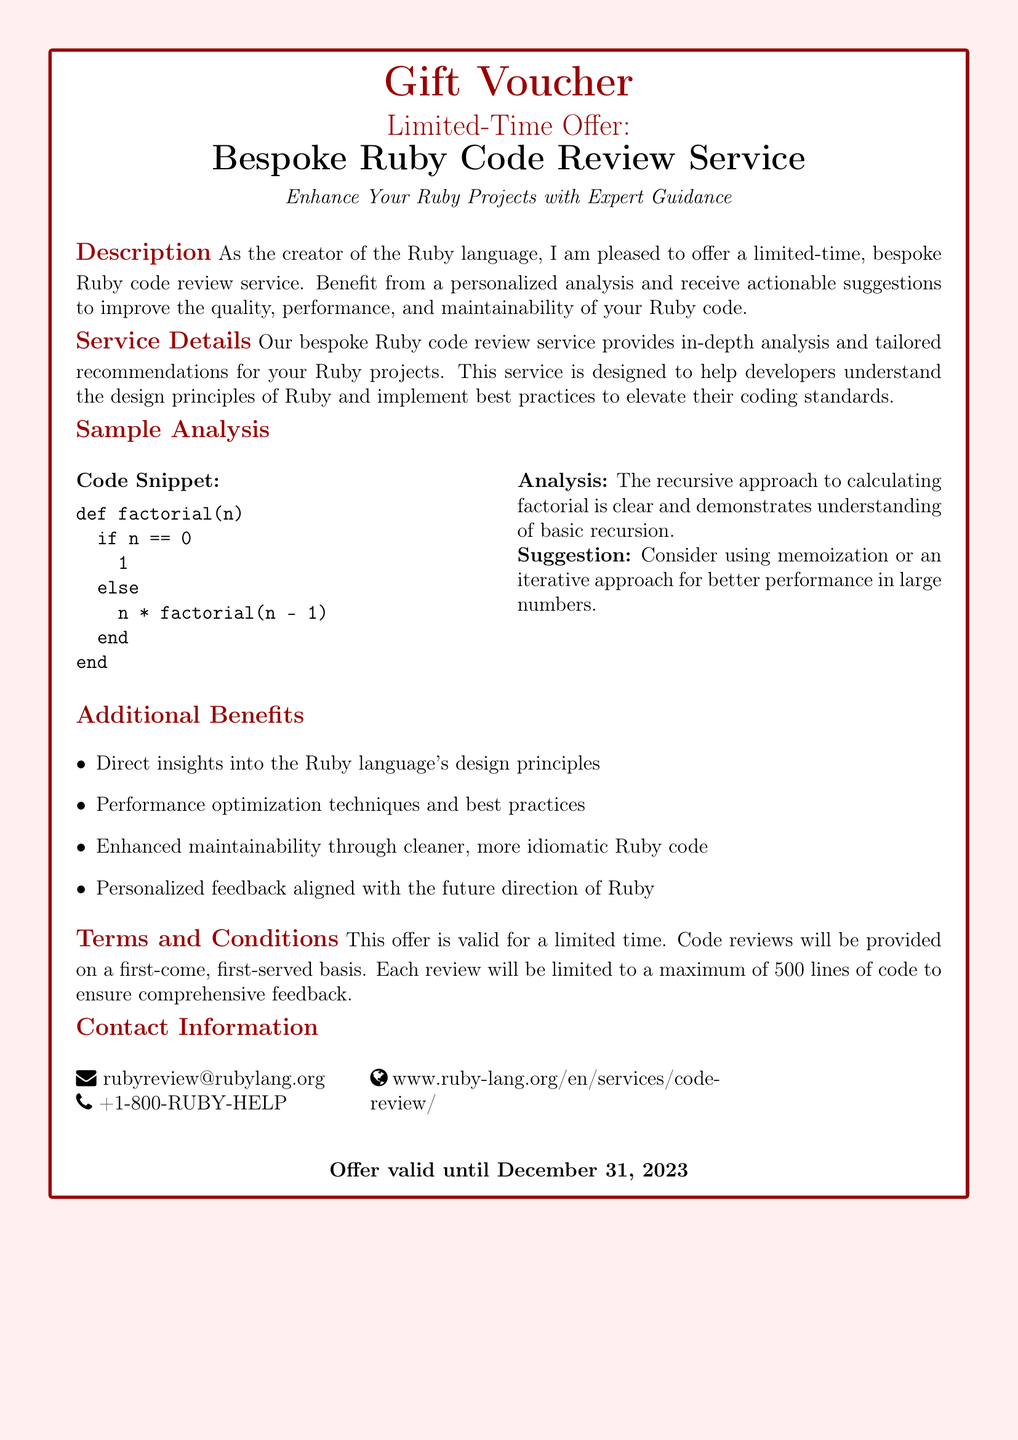What is the title of the service offered? The title of the service is prominently displayed in the document and is “Bespoke Ruby Code Review Service.”
Answer: Bespoke Ruby Code Review Service What is the maximum number of lines allowed for code reviews? The document specifies that each review will be limited to a maximum of 500 lines of code.
Answer: 500 lines When does the offer expire? The expiration date for the offer is clearly stated at the bottom of the document as December 31, 2023.
Answer: December 31, 2023 What type of analysis does the service provide? The document mentions "personalized analysis and receive actionable suggestions," indicating the approach taken in the reviews.
Answer: Personalized analysis What technique is suggested for better performance in the sample analysis? The analysis section includes a suggestion to use "memoization or an iterative approach" for improved performance.
Answer: Memoization What contact method is provided for inquiries? The document includes an email address for questions, which is "rubyreview@rubylang.org."
Answer: rubyreview@rubylang.org What specific additional benefit is mentioned in the document? The document lists multiple benefits, and one is "Direct insights into the Ruby language's design principles."
Answer: Direct insights into design principles What does the offer enhance? The document clearly states that the service aims to "Enhance Your Ruby Projects with Expert Guidance."
Answer: Enhance Your Ruby Projects 